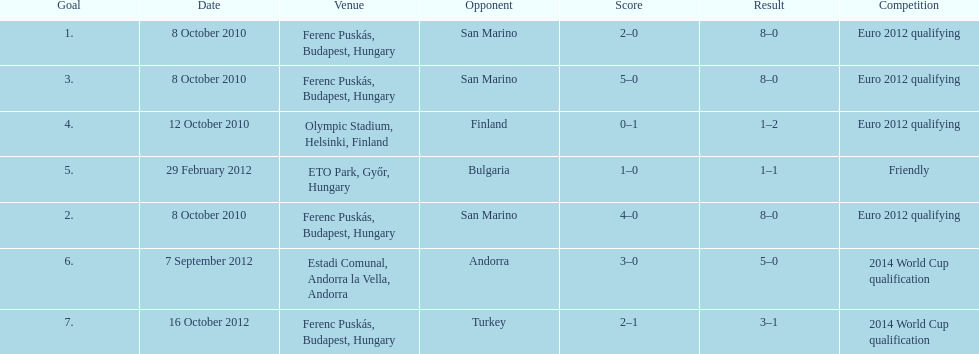How many games did he score but his team lost? 1. 